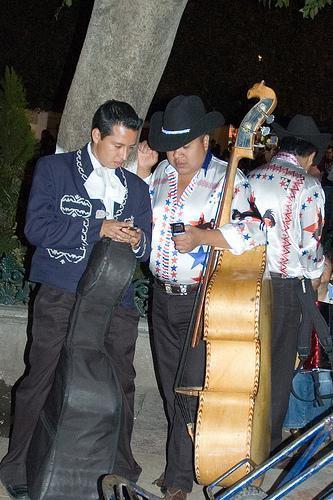How many men are there?
Give a very brief answer. 3. 